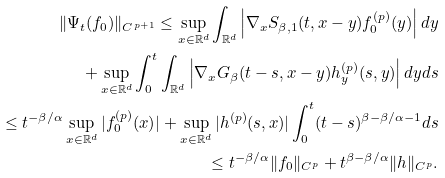<formula> <loc_0><loc_0><loc_500><loc_500>\| \Psi _ { t } ( f _ { 0 } ) \| _ { C ^ { p + 1 } } \leq \sup _ { x \in \mathbb { R } ^ { d } } \int _ { \mathbb { R } ^ { d } } \left | \nabla _ { x } S _ { \beta , 1 } ( t , x - y ) f _ { 0 } ^ { ( p ) } ( y ) \right | d y \\ + \sup _ { x \in \mathbb { R } ^ { d } } \int _ { 0 } ^ { t } \int _ { \mathbb { R } ^ { d } } \left | \nabla _ { x } G _ { \beta } ( t - s , x - y ) h ^ { ( p ) } _ { y } ( s , y ) \right | d y d s \\ \leq t ^ { - \beta / \alpha } \sup _ { x \in \mathbb { R } ^ { d } } | f _ { 0 } ^ { ( p ) } ( x ) | + \sup _ { x \in \mathbb { R } ^ { d } } | h ^ { ( p ) } ( s , x ) | \int _ { 0 } ^ { t } ( t - s ) ^ { \beta - \beta / \alpha - 1 } d s \\ \leq t ^ { - \beta / \alpha } \| f _ { 0 } \| _ { C ^ { p } } + t ^ { \beta - \beta / \alpha } \| h \| _ { C ^ { p } } .</formula> 